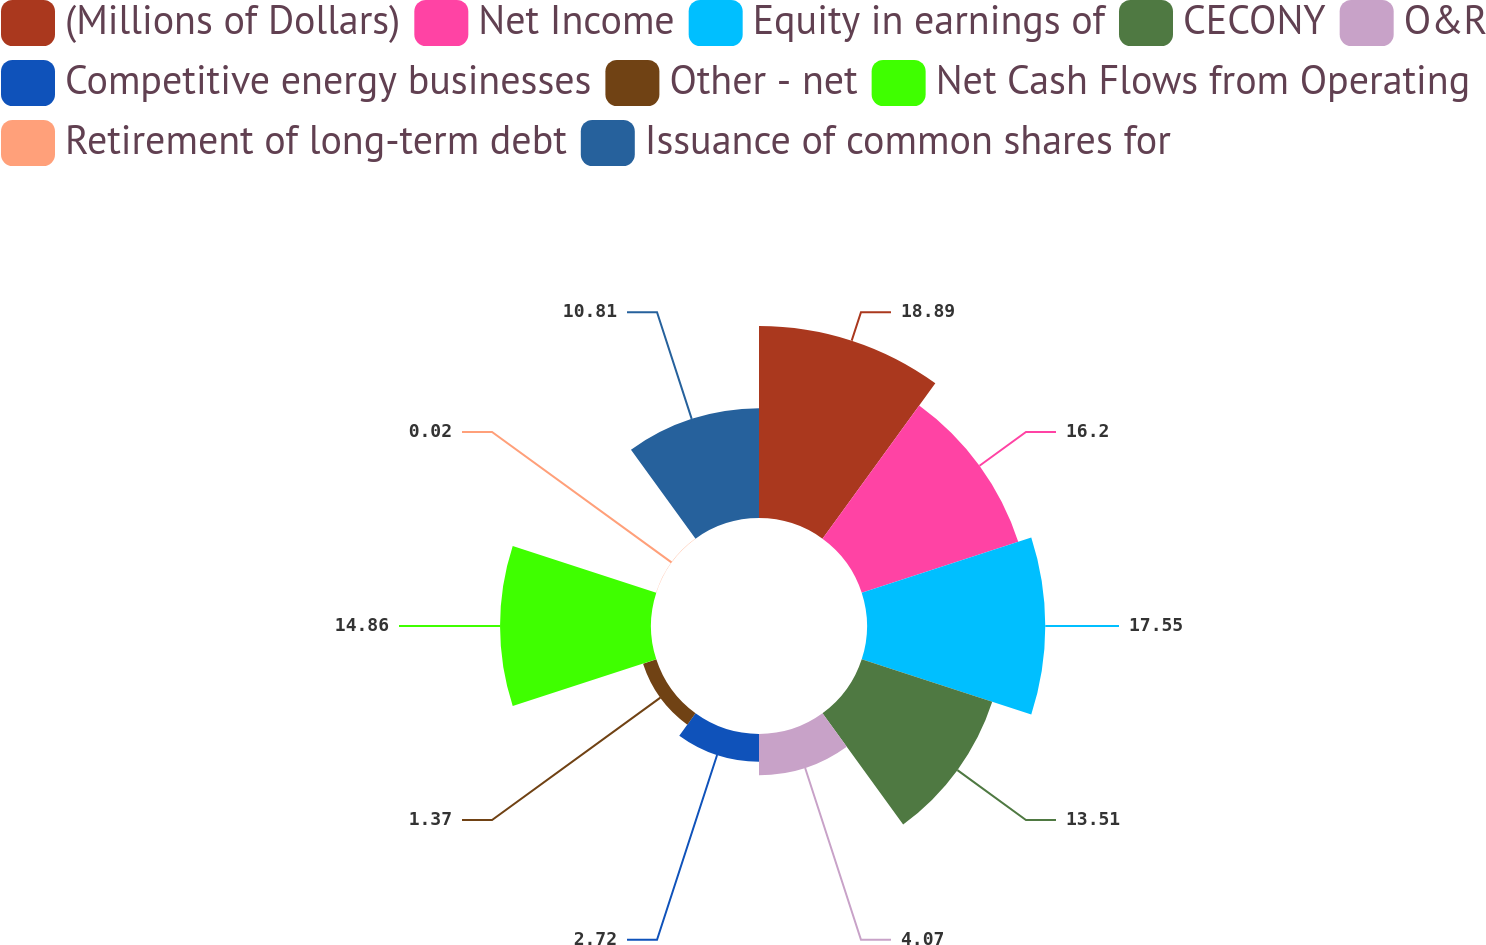Convert chart to OTSL. <chart><loc_0><loc_0><loc_500><loc_500><pie_chart><fcel>(Millions of Dollars)<fcel>Net Income<fcel>Equity in earnings of<fcel>CECONY<fcel>O&R<fcel>Competitive energy businesses<fcel>Other - net<fcel>Net Cash Flows from Operating<fcel>Retirement of long-term debt<fcel>Issuance of common shares for<nl><fcel>18.9%<fcel>16.2%<fcel>17.55%<fcel>13.51%<fcel>4.07%<fcel>2.72%<fcel>1.37%<fcel>14.86%<fcel>0.02%<fcel>10.81%<nl></chart> 